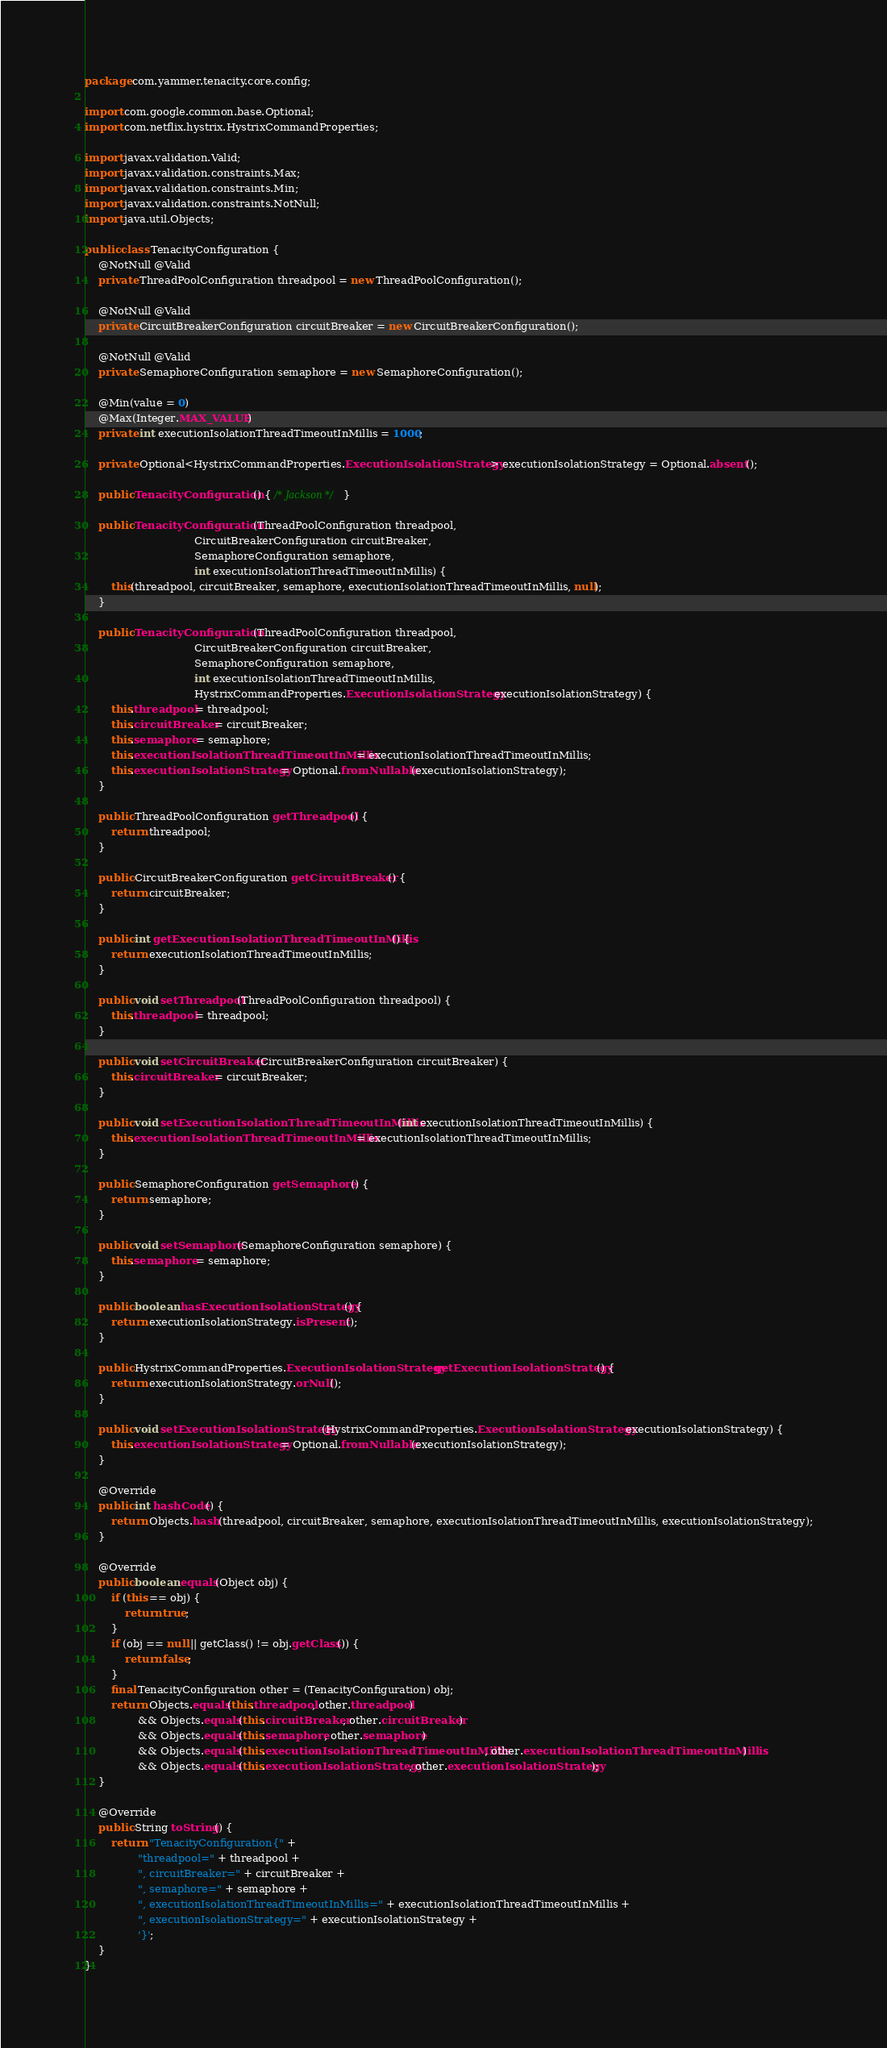<code> <loc_0><loc_0><loc_500><loc_500><_Java_>package com.yammer.tenacity.core.config;

import com.google.common.base.Optional;
import com.netflix.hystrix.HystrixCommandProperties;

import javax.validation.Valid;
import javax.validation.constraints.Max;
import javax.validation.constraints.Min;
import javax.validation.constraints.NotNull;
import java.util.Objects;

public class TenacityConfiguration {
    @NotNull @Valid
    private ThreadPoolConfiguration threadpool = new ThreadPoolConfiguration();

    @NotNull @Valid
    private CircuitBreakerConfiguration circuitBreaker = new CircuitBreakerConfiguration();

    @NotNull @Valid
    private SemaphoreConfiguration semaphore = new SemaphoreConfiguration();

    @Min(value = 0)
    @Max(Integer.MAX_VALUE)
    private int executionIsolationThreadTimeoutInMillis = 1000;

    private Optional<HystrixCommandProperties.ExecutionIsolationStrategy> executionIsolationStrategy = Optional.absent();

    public TenacityConfiguration() { /* Jackson */ }

    public TenacityConfiguration(ThreadPoolConfiguration threadpool,
                                 CircuitBreakerConfiguration circuitBreaker,
                                 SemaphoreConfiguration semaphore,
                                 int executionIsolationThreadTimeoutInMillis) {
        this(threadpool, circuitBreaker, semaphore, executionIsolationThreadTimeoutInMillis, null);
    }

    public TenacityConfiguration(ThreadPoolConfiguration threadpool,
                                 CircuitBreakerConfiguration circuitBreaker,
                                 SemaphoreConfiguration semaphore,
                                 int executionIsolationThreadTimeoutInMillis,
                                 HystrixCommandProperties.ExecutionIsolationStrategy executionIsolationStrategy) {
        this.threadpool = threadpool;
        this.circuitBreaker = circuitBreaker;
        this.semaphore = semaphore;
        this.executionIsolationThreadTimeoutInMillis = executionIsolationThreadTimeoutInMillis;
        this.executionIsolationStrategy = Optional.fromNullable(executionIsolationStrategy);
    }

    public ThreadPoolConfiguration getThreadpool() {
        return threadpool;
    }

    public CircuitBreakerConfiguration getCircuitBreaker() {
        return circuitBreaker;
    }

    public int getExecutionIsolationThreadTimeoutInMillis() {
        return executionIsolationThreadTimeoutInMillis;
    }

    public void setThreadpool(ThreadPoolConfiguration threadpool) {
        this.threadpool = threadpool;
    }

    public void setCircuitBreaker(CircuitBreakerConfiguration circuitBreaker) {
        this.circuitBreaker = circuitBreaker;
    }

    public void setExecutionIsolationThreadTimeoutInMillis(int executionIsolationThreadTimeoutInMillis) {
        this.executionIsolationThreadTimeoutInMillis = executionIsolationThreadTimeoutInMillis;
    }

    public SemaphoreConfiguration getSemaphore() {
        return semaphore;
    }

    public void setSemaphore(SemaphoreConfiguration semaphore) {
        this.semaphore = semaphore;
    }

    public boolean hasExecutionIsolationStrategy() {
        return executionIsolationStrategy.isPresent();
    }

    public HystrixCommandProperties.ExecutionIsolationStrategy getExecutionIsolationStrategy() {
        return executionIsolationStrategy.orNull();
    }

    public void setExecutionIsolationStrategy(HystrixCommandProperties.ExecutionIsolationStrategy executionIsolationStrategy) {
        this.executionIsolationStrategy = Optional.fromNullable(executionIsolationStrategy);
    }

    @Override
    public int hashCode() {
        return Objects.hash(threadpool, circuitBreaker, semaphore, executionIsolationThreadTimeoutInMillis, executionIsolationStrategy);
    }

    @Override
    public boolean equals(Object obj) {
        if (this == obj) {
            return true;
        }
        if (obj == null || getClass() != obj.getClass()) {
            return false;
        }
        final TenacityConfiguration other = (TenacityConfiguration) obj;
        return Objects.equals(this.threadpool, other.threadpool)
                && Objects.equals(this.circuitBreaker, other.circuitBreaker)
                && Objects.equals(this.semaphore, other.semaphore)
                && Objects.equals(this.executionIsolationThreadTimeoutInMillis, other.executionIsolationThreadTimeoutInMillis)
                && Objects.equals(this.executionIsolationStrategy, other.executionIsolationStrategy);
    }

    @Override
    public String toString() {
        return "TenacityConfiguration{" +
                "threadpool=" + threadpool +
                ", circuitBreaker=" + circuitBreaker +
                ", semaphore=" + semaphore +
                ", executionIsolationThreadTimeoutInMillis=" + executionIsolationThreadTimeoutInMillis +
                ", executionIsolationStrategy=" + executionIsolationStrategy +
                '}';
    }
}</code> 